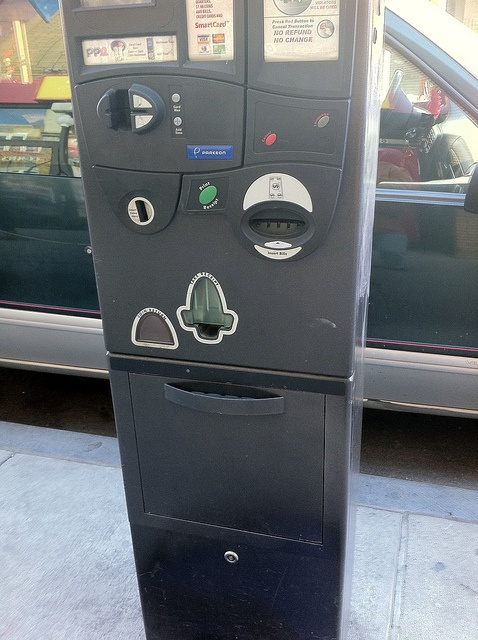Describe the objects in this image and their specific colors. I can see parking meter in gray, black, ivory, and darkgray tones and truck in gray, black, darkgray, and ivory tones in this image. 